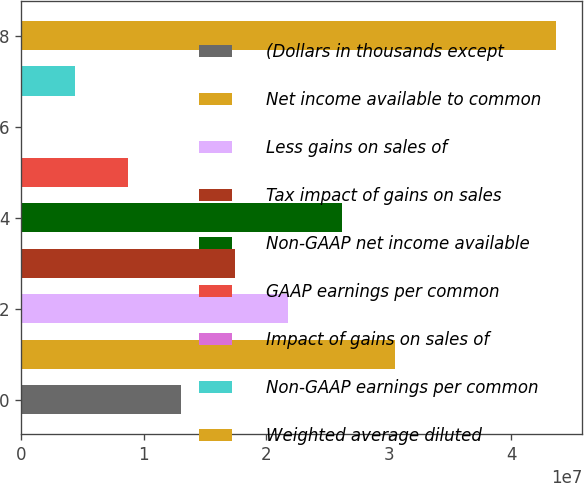Convert chart to OTSL. <chart><loc_0><loc_0><loc_500><loc_500><bar_chart><fcel>(Dollars in thousands except<fcel>Net income available to common<fcel>Less gains on sales of<fcel>Tax impact of gains on sales<fcel>Non-GAAP net income available<fcel>GAAP earnings per common<fcel>Impact of gains on sales of<fcel>Non-GAAP earnings per common<fcel>Weighted average diluted<nl><fcel>1.30911e+07<fcel>3.05458e+07<fcel>2.18184e+07<fcel>1.74547e+07<fcel>2.61821e+07<fcel>8.72737e+06<fcel>0.86<fcel>4.36369e+06<fcel>4.36369e+07<nl></chart> 